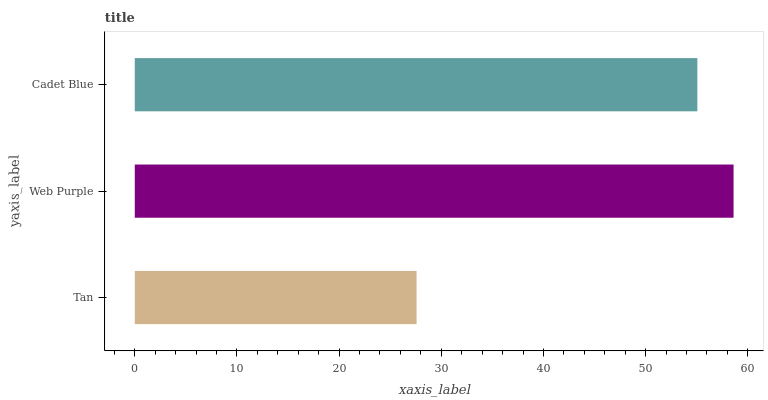Is Tan the minimum?
Answer yes or no. Yes. Is Web Purple the maximum?
Answer yes or no. Yes. Is Cadet Blue the minimum?
Answer yes or no. No. Is Cadet Blue the maximum?
Answer yes or no. No. Is Web Purple greater than Cadet Blue?
Answer yes or no. Yes. Is Cadet Blue less than Web Purple?
Answer yes or no. Yes. Is Cadet Blue greater than Web Purple?
Answer yes or no. No. Is Web Purple less than Cadet Blue?
Answer yes or no. No. Is Cadet Blue the high median?
Answer yes or no. Yes. Is Cadet Blue the low median?
Answer yes or no. Yes. Is Web Purple the high median?
Answer yes or no. No. Is Tan the low median?
Answer yes or no. No. 